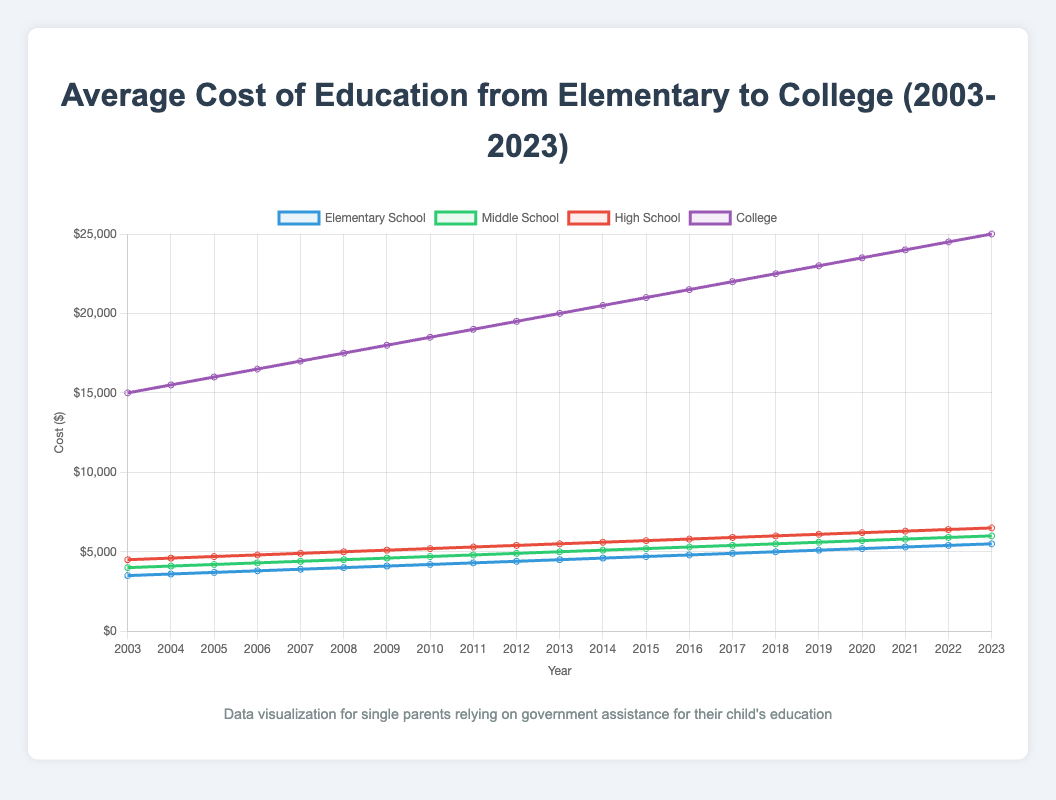What is the overall trend in the cost of college education from 2003 to 2023? By looking at the line representing college costs, it consistently moves upward from 2003 to 2023, showing an increasing trend.
Answer: Increasing Which year shows the highest cost for middle school education? The middle school line in the graph reaches its highest point in 2023, so this year has the highest cost.
Answer: 2023 How much has the cost of elementary school education increased from 2003 to 2023? The cost of elementary school education in 2003 is $3,500 and in 2023 it's $5,500. The increase is $5,500 - $3,500 = $2,000.
Answer: $2,000 Between middle school and high school, which had a higher cost in 2010? Observing the lines on the graph, in 2010, the cost of high school ($5,200) is higher than that of middle school ($4,700).
Answer: High School What is the average cost of education for college over the last 20 years? To find the average, sum all the annual college costs from 2003 to 2023 and divide by the number of years: [(15000 + 15500 + 16000 + ... + 25000)/21] = $20,571.43.
Answer: $20,571.43 Which level of education shows the steepest increase in cost between 2003 and 2023? By comparing the slopes of the lines, the college cost line has the steepest increase, rising from $15,000 in 2003 to $25,000 in 2023; a $10,000 increase.
Answer: College What was the cost difference between high school education and college education in 2008? In 2008, the high school cost is $5,000 and college cost is $17,500, so the difference is $17,500 - $5,000 = $12,500.
Answer: $12,500 In which years did the cost of elementary school education exceed $5,000? Observing the graph, the cost of elementary school education exceeded $5,000 starting from 2018 onwards.
Answer: 2018-2023 Describe the trend for high school education costs over this period. The high school cost line shows a continuous upward trend from 2003 ($4,500) to 2023 ($6,500), indicating an increase throughout the period.
Answer: Increasing 